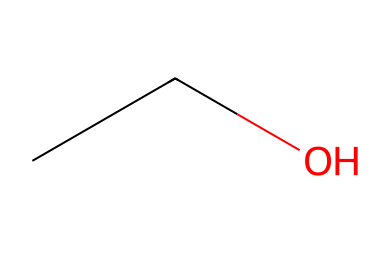How many carbon atoms are in ethanol? The SMILES representation "CCO" indicates that there are two carbon atoms (C) in the chain. The two "C" letters each represent a carbon atom.
Answer: 2 What is the functional group present in ethanol? In the structure "CCO," the "O" at the end indicates the presence of a hydroxyl group (-OH), which is the functional group responsible for alcohol properties.
Answer: hydroxyl Which type of isomerism could ethanol exhibit? Ethanol has a straightforward structure without branching, meaning it doesn't have structural isomers; however, it can exhibit stereoisomerism due to its unbranched chain resulting in no chiral centers. Therefore, it primarily does not exhibit significant isomerism.
Answer: none What state of matter is ethanol at room temperature? Ethanol, as indicated by its molecular structure, is a liquid at room temperature (which is around 20-25 degrees Celsius), making it suitable for use in beverages.
Answer: liquid How many hydrogen atoms are in ethanol? The structure represented by the SMILES "CCO" suggests that for each carbon atom, two hydrogen atoms are typically attached, plus one more from the hydroxyl group; therefore, there are a total of six hydrogen atoms.
Answer: 6 What kind of alcohol is represented by this structure? Ethanol is the specific name for the alcohol represented by the SMILES "CCO," which is classified as a simple alcohol and is specifically categorized as a primary alcohol because of its structure.
Answer: primary alcohol 